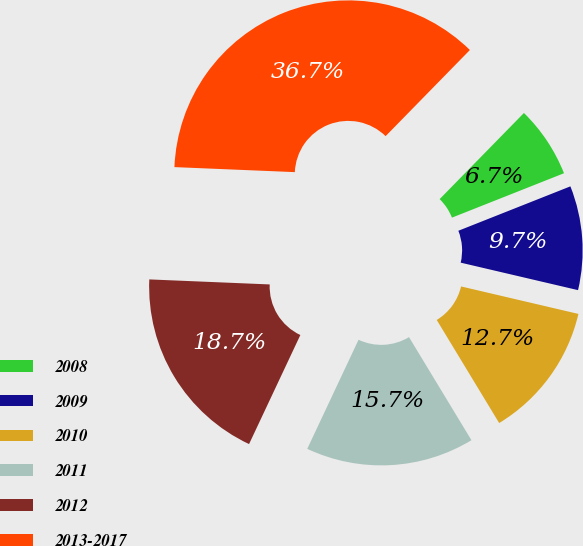Convert chart to OTSL. <chart><loc_0><loc_0><loc_500><loc_500><pie_chart><fcel>2008<fcel>2009<fcel>2010<fcel>2011<fcel>2012<fcel>2013-2017<nl><fcel>6.67%<fcel>9.67%<fcel>12.67%<fcel>15.67%<fcel>18.67%<fcel>36.67%<nl></chart> 